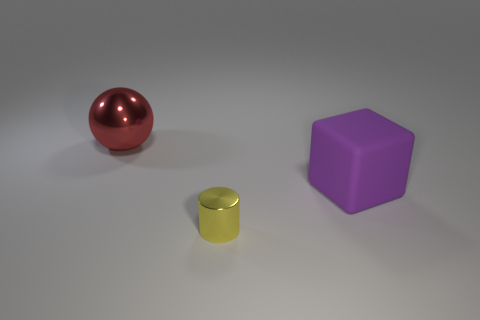What materials do the objects seem to be made of? The sphere has a reflective surface that suggests it might be made of a polished metal. The cylinder has a slightly matte finish, possibly indicative of plastic or metal, while the cube appears to have a solid, possibly plastic make with a matte finish as well. 